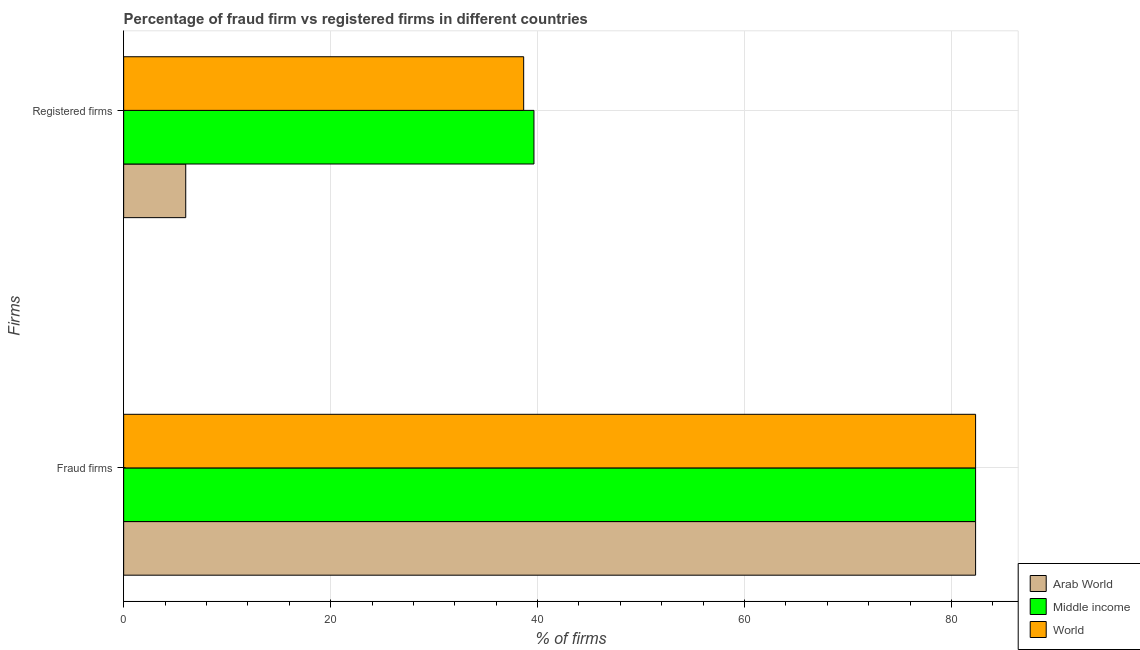How many bars are there on the 2nd tick from the top?
Ensure brevity in your answer.  3. How many bars are there on the 2nd tick from the bottom?
Ensure brevity in your answer.  3. What is the label of the 1st group of bars from the top?
Provide a succinct answer. Registered firms. What is the percentage of fraud firms in World?
Your response must be concise. 82.33. Across all countries, what is the maximum percentage of fraud firms?
Give a very brief answer. 82.33. Across all countries, what is the minimum percentage of fraud firms?
Offer a very short reply. 82.33. In which country was the percentage of fraud firms maximum?
Offer a very short reply. Arab World. In which country was the percentage of fraud firms minimum?
Ensure brevity in your answer.  Arab World. What is the total percentage of fraud firms in the graph?
Your response must be concise. 246.99. What is the difference between the percentage of registered firms in Middle income and that in World?
Give a very brief answer. 0.99. What is the difference between the percentage of fraud firms in Middle income and the percentage of registered firms in World?
Give a very brief answer. 43.67. What is the average percentage of fraud firms per country?
Give a very brief answer. 82.33. What is the difference between the percentage of fraud firms and percentage of registered firms in Arab World?
Keep it short and to the point. 76.33. What is the ratio of the percentage of registered firms in Middle income to that in World?
Provide a succinct answer. 1.03. How many bars are there?
Make the answer very short. 6. Are all the bars in the graph horizontal?
Provide a succinct answer. Yes. Are the values on the major ticks of X-axis written in scientific E-notation?
Your answer should be very brief. No. Where does the legend appear in the graph?
Keep it short and to the point. Bottom right. What is the title of the graph?
Your answer should be compact. Percentage of fraud firm vs registered firms in different countries. What is the label or title of the X-axis?
Give a very brief answer. % of firms. What is the label or title of the Y-axis?
Offer a very short reply. Firms. What is the % of firms of Arab World in Fraud firms?
Make the answer very short. 82.33. What is the % of firms in Middle income in Fraud firms?
Your answer should be compact. 82.33. What is the % of firms of World in Fraud firms?
Make the answer very short. 82.33. What is the % of firms in Arab World in Registered firms?
Provide a succinct answer. 6. What is the % of firms of Middle income in Registered firms?
Provide a succinct answer. 39.65. What is the % of firms in World in Registered firms?
Ensure brevity in your answer.  38.66. Across all Firms, what is the maximum % of firms of Arab World?
Offer a terse response. 82.33. Across all Firms, what is the maximum % of firms in Middle income?
Offer a very short reply. 82.33. Across all Firms, what is the maximum % of firms in World?
Offer a very short reply. 82.33. Across all Firms, what is the minimum % of firms of Arab World?
Make the answer very short. 6. Across all Firms, what is the minimum % of firms in Middle income?
Your answer should be compact. 39.65. Across all Firms, what is the minimum % of firms of World?
Keep it short and to the point. 38.66. What is the total % of firms in Arab World in the graph?
Ensure brevity in your answer.  88.33. What is the total % of firms in Middle income in the graph?
Keep it short and to the point. 121.98. What is the total % of firms of World in the graph?
Ensure brevity in your answer.  120.99. What is the difference between the % of firms in Arab World in Fraud firms and that in Registered firms?
Make the answer very short. 76.33. What is the difference between the % of firms of Middle income in Fraud firms and that in Registered firms?
Provide a short and direct response. 42.68. What is the difference between the % of firms in World in Fraud firms and that in Registered firms?
Keep it short and to the point. 43.67. What is the difference between the % of firms of Arab World in Fraud firms and the % of firms of Middle income in Registered firms?
Your response must be concise. 42.68. What is the difference between the % of firms of Arab World in Fraud firms and the % of firms of World in Registered firms?
Provide a succinct answer. 43.67. What is the difference between the % of firms of Middle income in Fraud firms and the % of firms of World in Registered firms?
Your answer should be compact. 43.67. What is the average % of firms of Arab World per Firms?
Provide a short and direct response. 44.16. What is the average % of firms in Middle income per Firms?
Provide a short and direct response. 60.99. What is the average % of firms in World per Firms?
Provide a succinct answer. 60.49. What is the difference between the % of firms of Arab World and % of firms of World in Fraud firms?
Ensure brevity in your answer.  0. What is the difference between the % of firms in Arab World and % of firms in Middle income in Registered firms?
Offer a very short reply. -33.65. What is the difference between the % of firms of Arab World and % of firms of World in Registered firms?
Provide a succinct answer. -32.66. What is the ratio of the % of firms in Arab World in Fraud firms to that in Registered firms?
Provide a succinct answer. 13.72. What is the ratio of the % of firms of Middle income in Fraud firms to that in Registered firms?
Offer a very short reply. 2.08. What is the ratio of the % of firms of World in Fraud firms to that in Registered firms?
Ensure brevity in your answer.  2.13. What is the difference between the highest and the second highest % of firms in Arab World?
Provide a short and direct response. 76.33. What is the difference between the highest and the second highest % of firms of Middle income?
Offer a very short reply. 42.68. What is the difference between the highest and the second highest % of firms of World?
Keep it short and to the point. 43.67. What is the difference between the highest and the lowest % of firms in Arab World?
Offer a very short reply. 76.33. What is the difference between the highest and the lowest % of firms of Middle income?
Your answer should be very brief. 42.68. What is the difference between the highest and the lowest % of firms in World?
Your response must be concise. 43.67. 